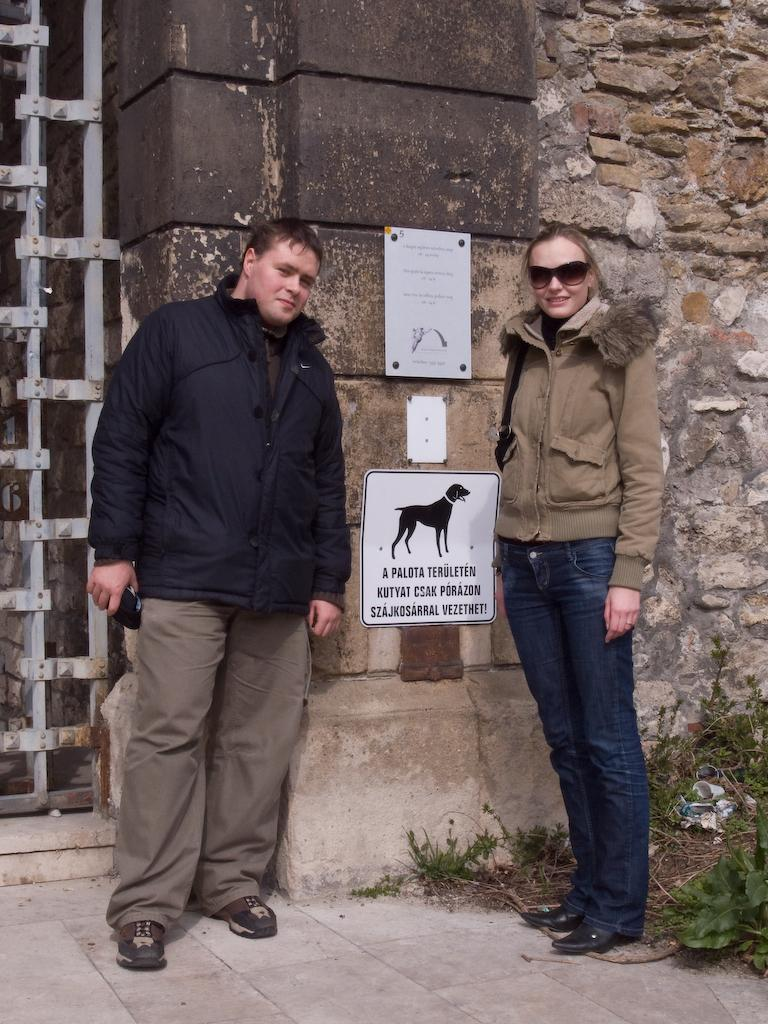Who are the two people in the image? There is a man and a lady standing in the center of the image. What can be seen in the background of the image? There is a wall in the background of the image. What is placed on the wall? Boards are placed on the wall. What is located on the left side of the image? There is a gate on the left side of the image. What type of horn is being played by the man in the image? There is no horn present in the image; the man and lady are simply standing in the center. 